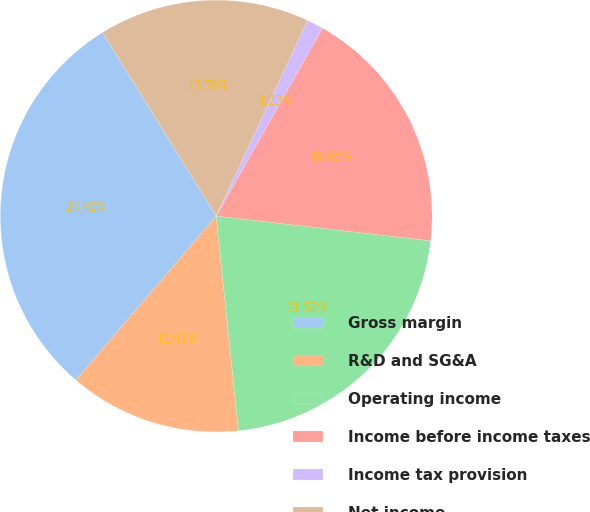<chart> <loc_0><loc_0><loc_500><loc_500><pie_chart><fcel>Gross margin<fcel>R&D and SG&A<fcel>Operating income<fcel>Income before income taxes<fcel>Income tax provision<fcel>Net income<nl><fcel>29.92%<fcel>12.91%<fcel>21.52%<fcel>18.65%<fcel>1.23%<fcel>15.78%<nl></chart> 